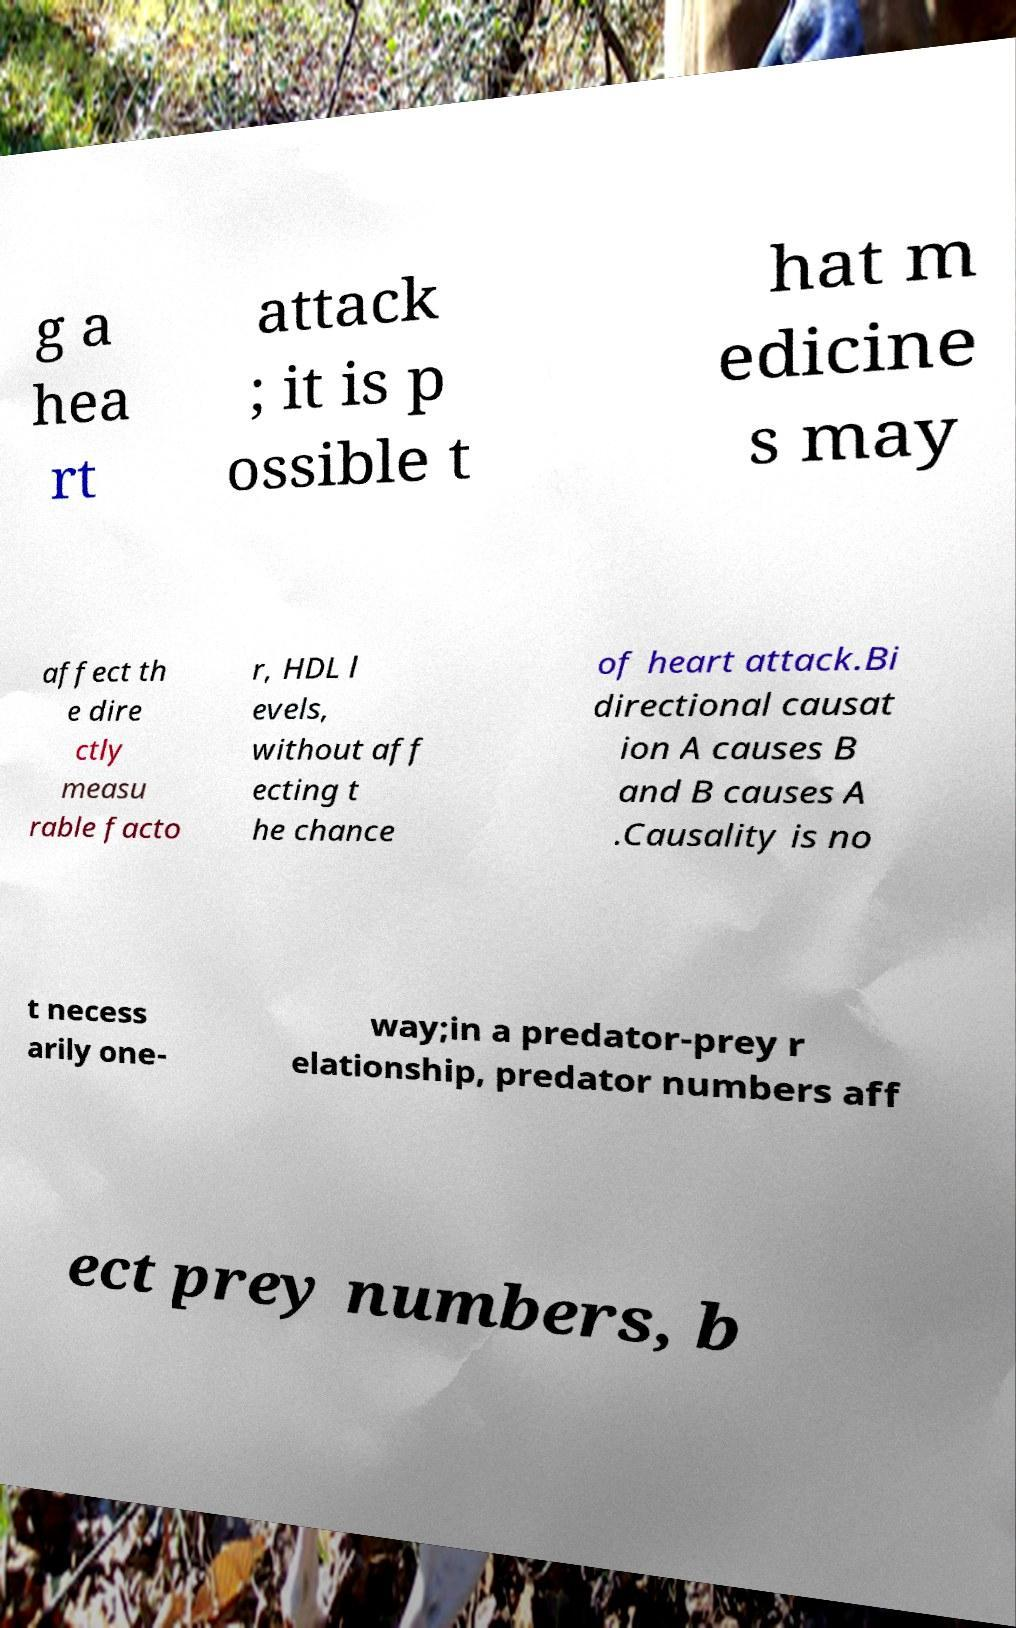For documentation purposes, I need the text within this image transcribed. Could you provide that? g a hea rt attack ; it is p ossible t hat m edicine s may affect th e dire ctly measu rable facto r, HDL l evels, without aff ecting t he chance of heart attack.Bi directional causat ion A causes B and B causes A .Causality is no t necess arily one- way;in a predator-prey r elationship, predator numbers aff ect prey numbers, b 